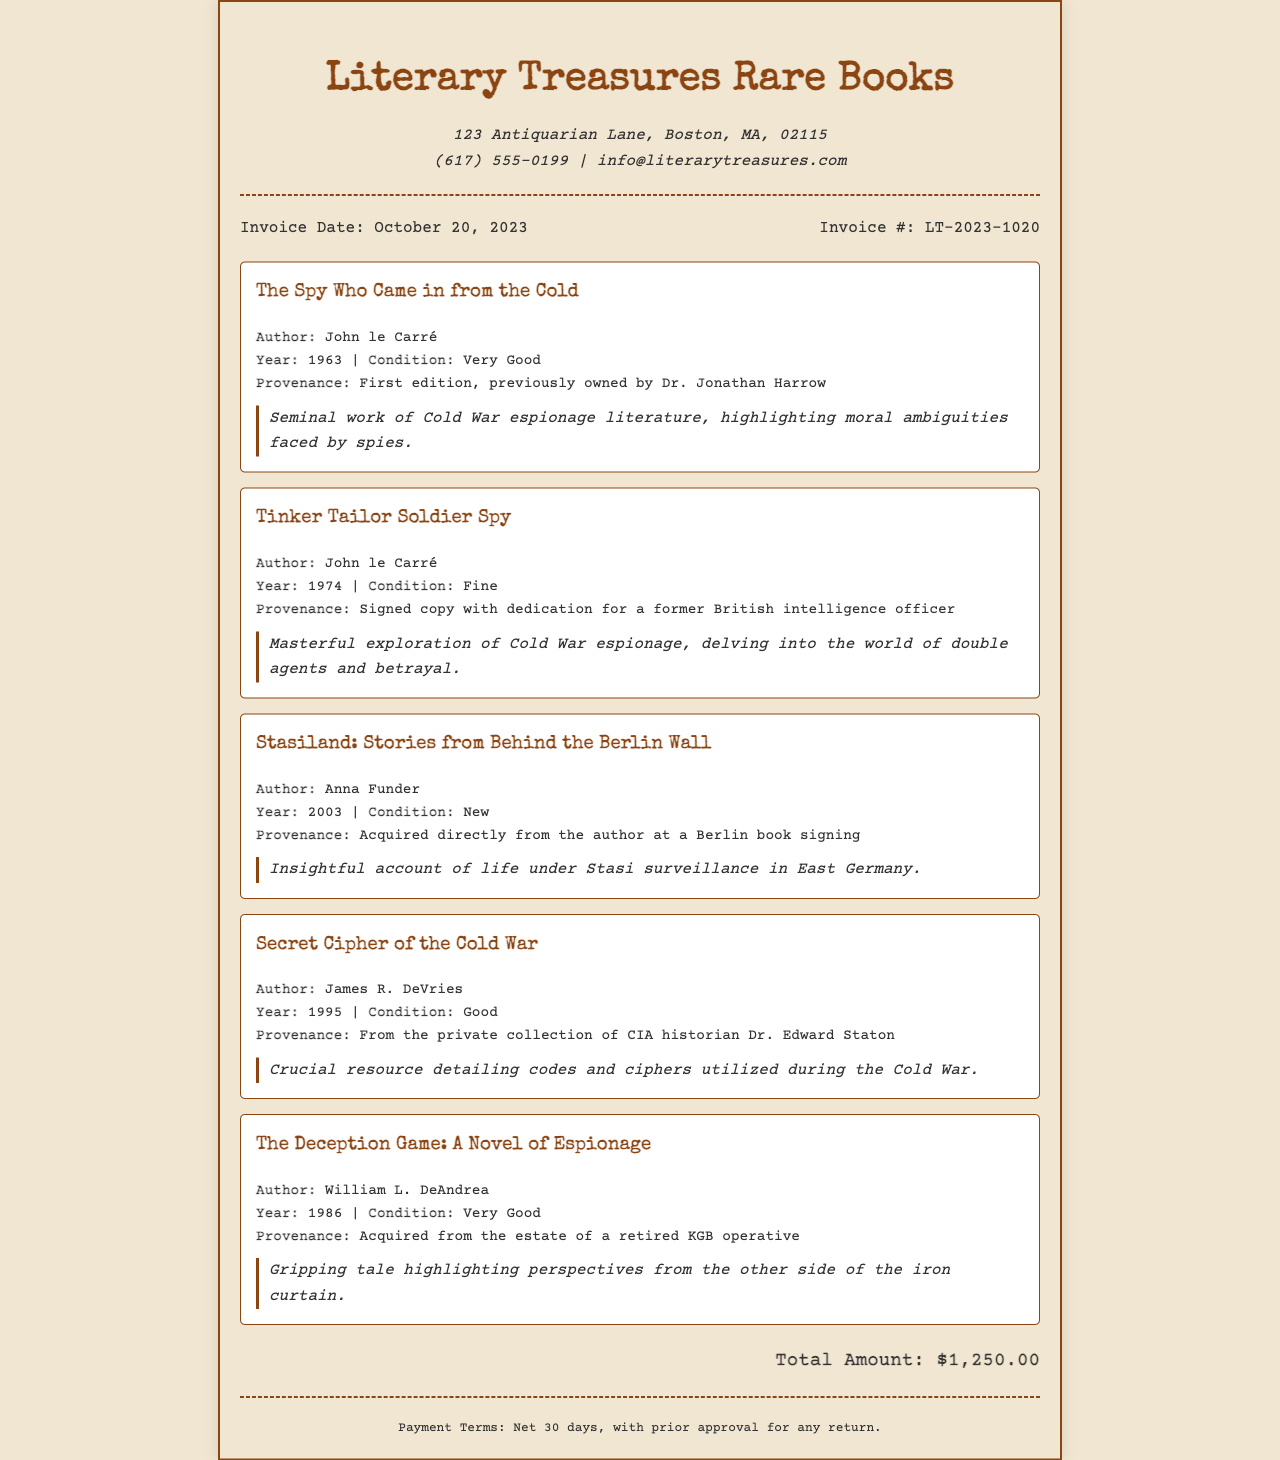What is the invoice date? The invoice date is explicitly stated in the document, which is October 20, 2023.
Answer: October 20, 2023 Who is the author of "The Spy Who Came in from the Cold"? The document lists the author's name next to the corresponding book title, revealing it is John le Carré.
Answer: John le Carré What condition is "Tinker Tailor Soldier Spy" in? The condition of the book is specified in the invoice details, stating it is in Fine condition.
Answer: Fine What is the provenance of "Stasiland: Stories from Behind the Berlin Wall"? The document contains a section that describes the provenance of the item, which indicates it was acquired directly from the author at a Berlin book signing.
Answer: Acquired directly from the author at a Berlin book signing How much is the total amount of the invoice? The total amount is clearly stated in the document as $1,250.00.
Answer: $1,250.00 What genre do all items in this invoice share? The documents relate specifically to espionage literature, which is the central theme.
Answer: Espionage literature What notable figure previously owned "The Spy Who Came in from the Cold"? The provenance information in the document reveals that it was previously owned by Dr. Jonathan Harrow.
Answer: Dr. Jonathan Harrow What are the payment terms stated in the invoice? The invoice includes a section detailing the payment terms, which specifically states Net 30 days, with prior approval for any return.
Answer: Net 30 days, with prior approval for any return Which book was acquired from the estate of a retired KGB operative? The provenance section mentions that "The Deception Game: A Novel of Espionage" was acquired from the estate of a retired KGB operative.
Answer: The Deception Game: A Novel of Espionage 